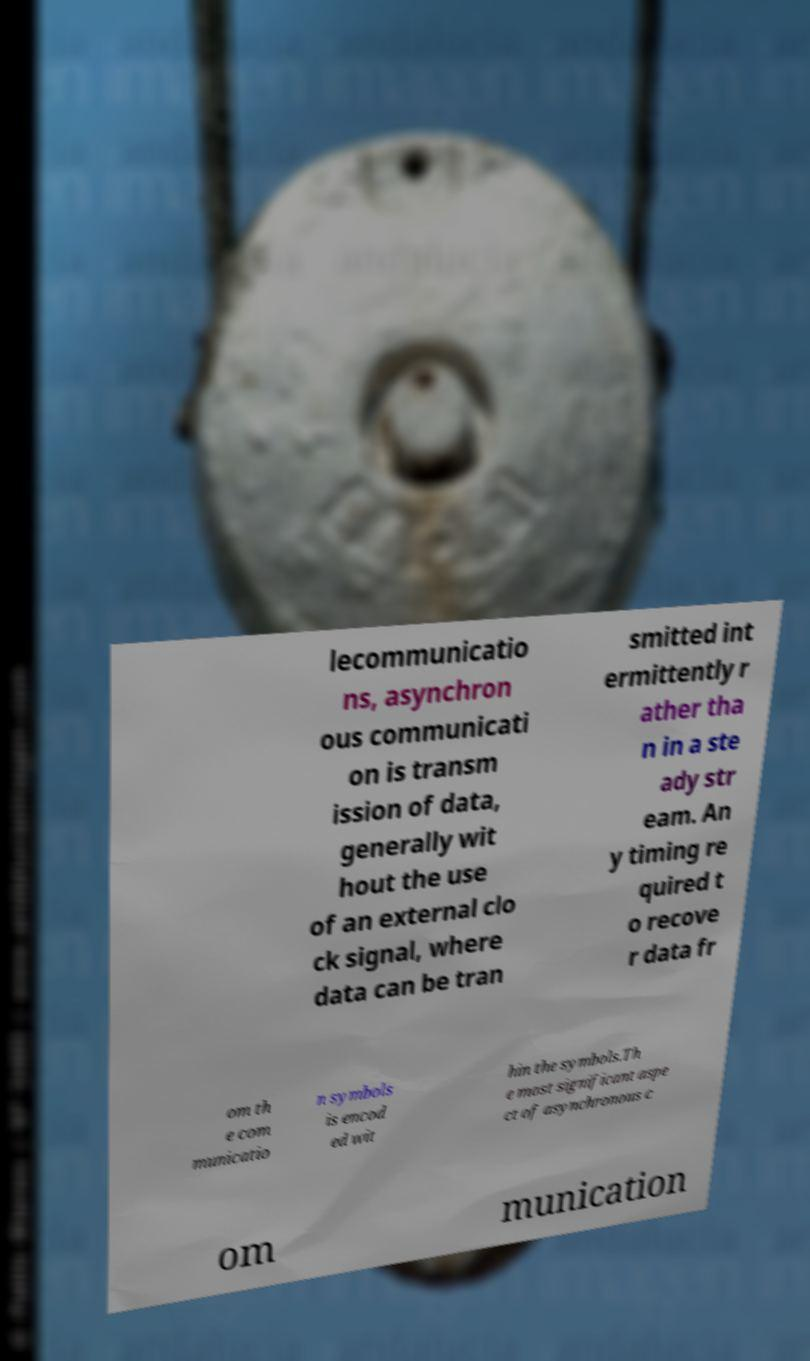Can you read and provide the text displayed in the image?This photo seems to have some interesting text. Can you extract and type it out for me? lecommunicatio ns, asynchron ous communicati on is transm ission of data, generally wit hout the use of an external clo ck signal, where data can be tran smitted int ermittently r ather tha n in a ste ady str eam. An y timing re quired t o recove r data fr om th e com municatio n symbols is encod ed wit hin the symbols.Th e most significant aspe ct of asynchronous c om munication 